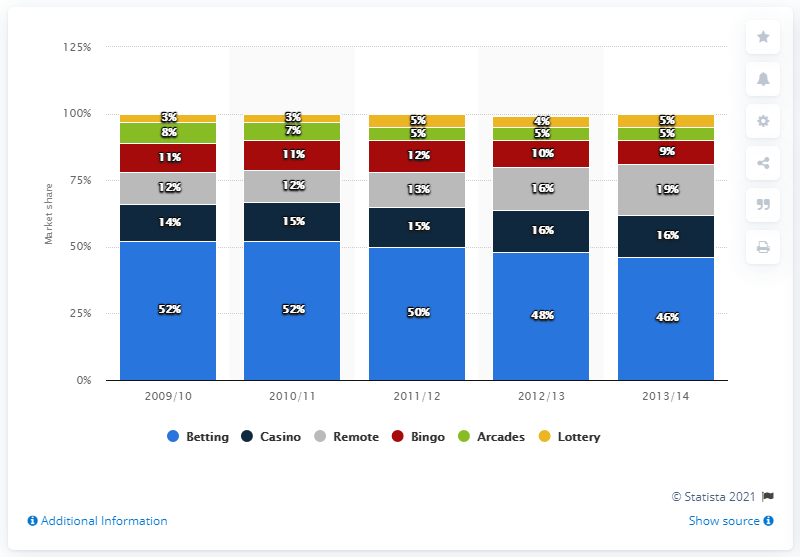Point out several critical features in this image. During the period of October 2012 to September 2013, bingo accounted for approximately X% of the gambling market. 